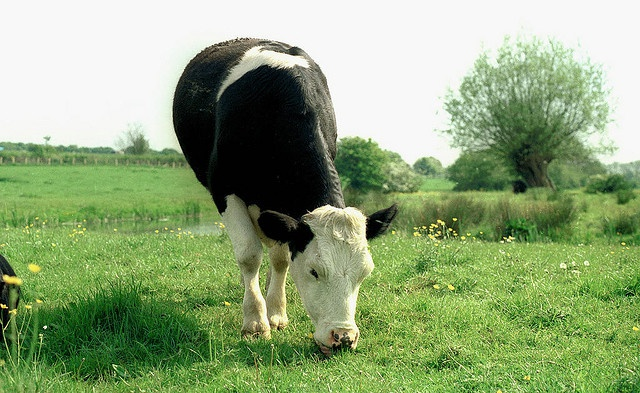Describe the objects in this image and their specific colors. I can see a cow in white, black, olive, gray, and darkgray tones in this image. 